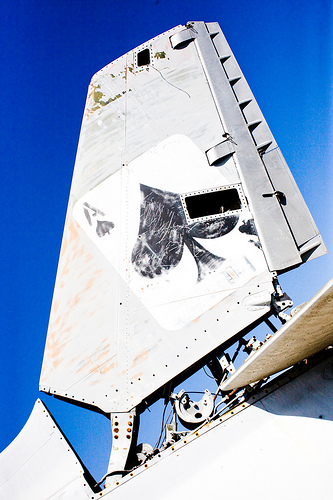<image>
Can you confirm if the card is on the tail rudder? Yes. Looking at the image, I can see the card is positioned on top of the tail rudder, with the tail rudder providing support. 